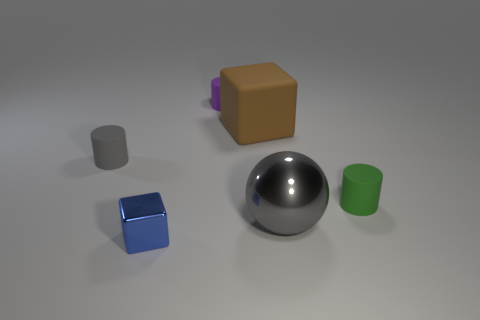Add 1 large blue rubber spheres. How many objects exist? 7 Subtract all blocks. How many objects are left? 4 Add 1 matte cylinders. How many matte cylinders are left? 4 Add 2 brown cylinders. How many brown cylinders exist? 2 Subtract 1 green cylinders. How many objects are left? 5 Subtract all small purple spheres. Subtract all gray shiny balls. How many objects are left? 5 